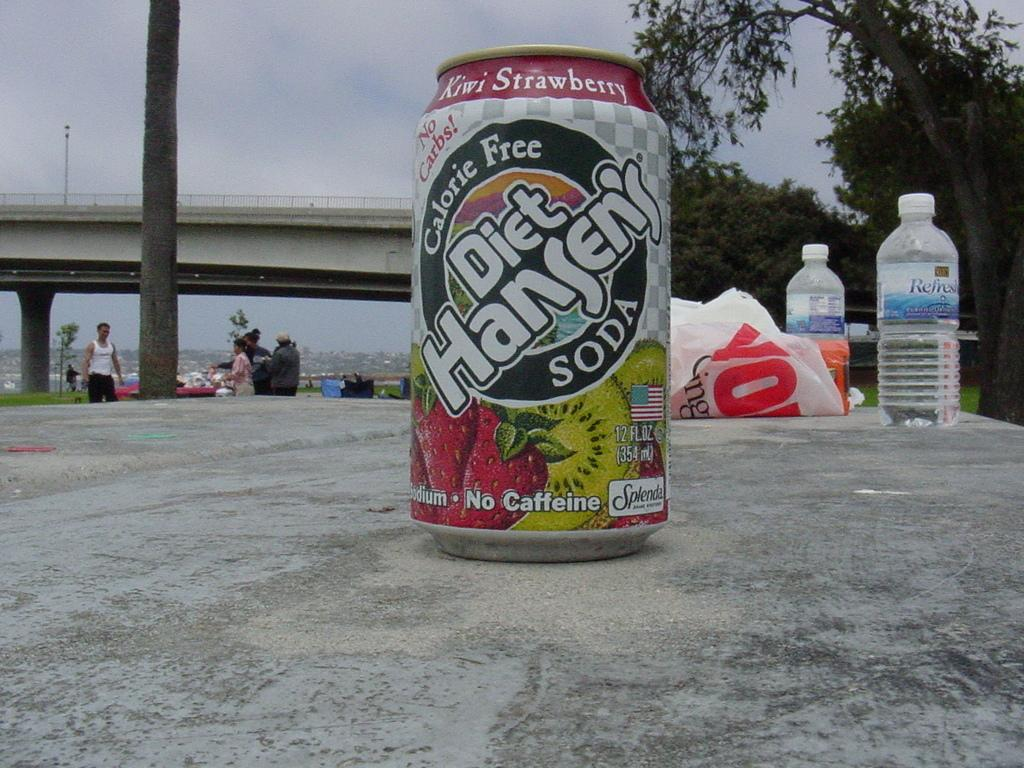<image>
Summarize the visual content of the image. a diet Hansen's soda standing in front of bottled water 